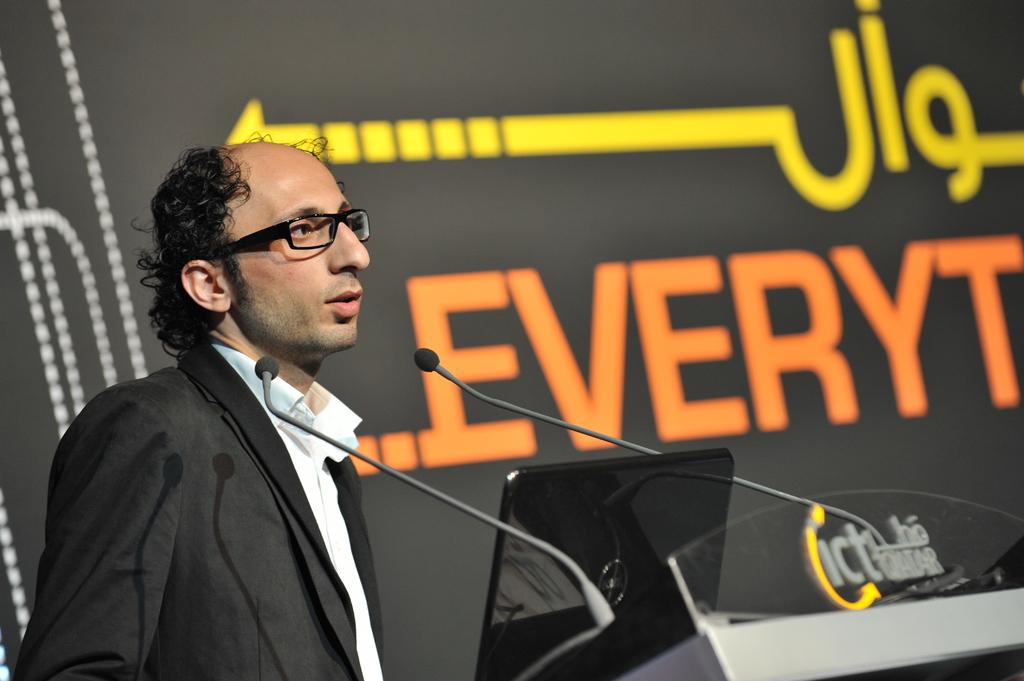Who is present in the image? There is a man in the image. What is the man wearing? The man is wearing a shirt and a blazer. What accessory is the man wearing? The man is wearing spectacles. Where is the man located in the image? The man is on the right side of the image. What equipment is present in the image? There is a podium system and microphones in the image. What else can be seen in the image? There is a poster in the image. What type of flesh can be seen on the street in the image? There is no flesh or street present in the image; it features a man with a podium system, microphones, and a poster. 